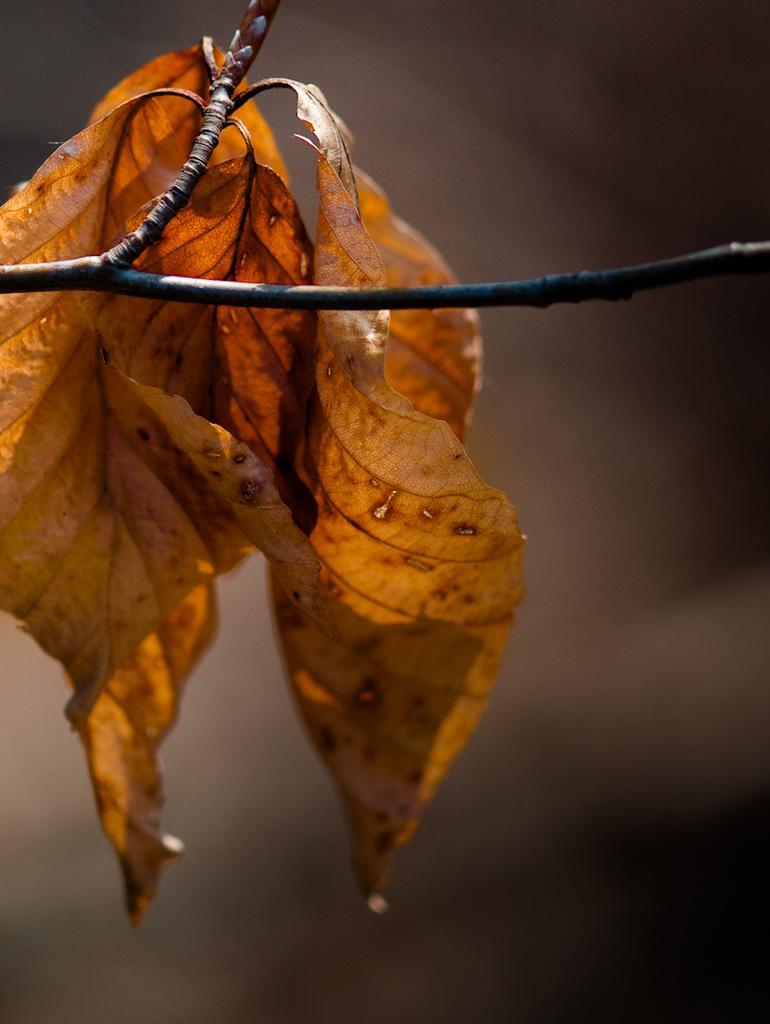Please provide a concise description of this image. In the foreground of this picture, there are four leafs to the branch of a tree and the background is blurred. 